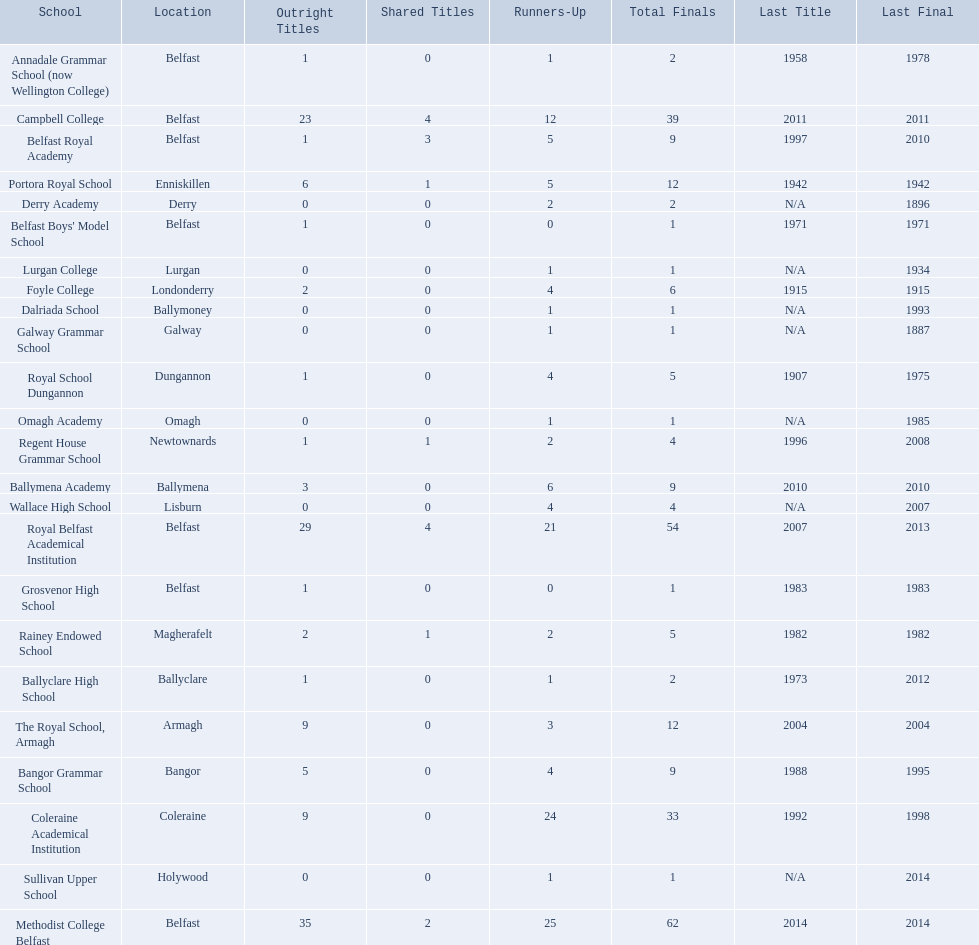What were all of the school names? Methodist College Belfast, Royal Belfast Academical Institution, Campbell College, Coleraine Academical Institution, The Royal School, Armagh, Portora Royal School, Bangor Grammar School, Ballymena Academy, Rainey Endowed School, Foyle College, Belfast Royal Academy, Regent House Grammar School, Royal School Dungannon, Annadale Grammar School (now Wellington College), Ballyclare High School, Belfast Boys' Model School, Grosvenor High School, Wallace High School, Derry Academy, Dalriada School, Galway Grammar School, Lurgan College, Omagh Academy, Sullivan Upper School. How many outright titles did they achieve? 35, 29, 23, 9, 9, 6, 5, 3, 2, 2, 1, 1, 1, 1, 1, 1, 1, 0, 0, 0, 0, 0, 0, 0. And how many did coleraine academical institution receive? 9. Which other school had the same number of outright titles? The Royal School, Armagh. 